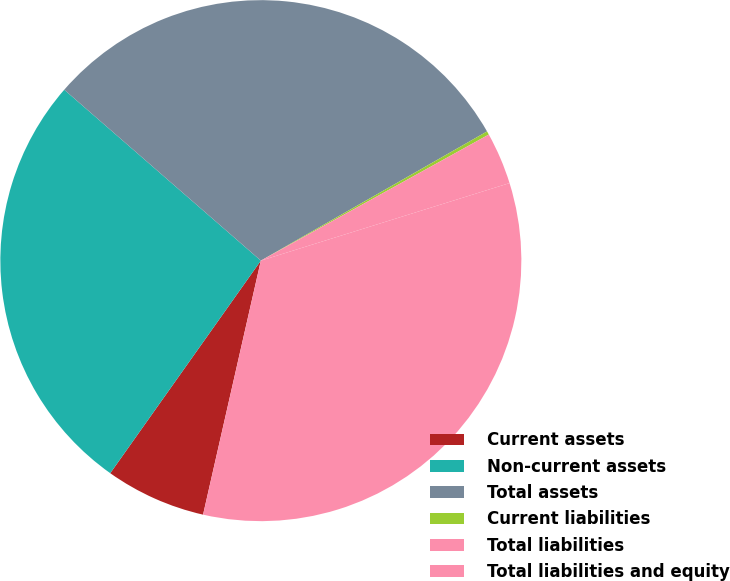<chart> <loc_0><loc_0><loc_500><loc_500><pie_chart><fcel>Current assets<fcel>Non-current assets<fcel>Total assets<fcel>Current liabilities<fcel>Total liabilities<fcel>Total liabilities and equity<nl><fcel>6.25%<fcel>26.58%<fcel>30.35%<fcel>0.22%<fcel>3.23%<fcel>33.37%<nl></chart> 